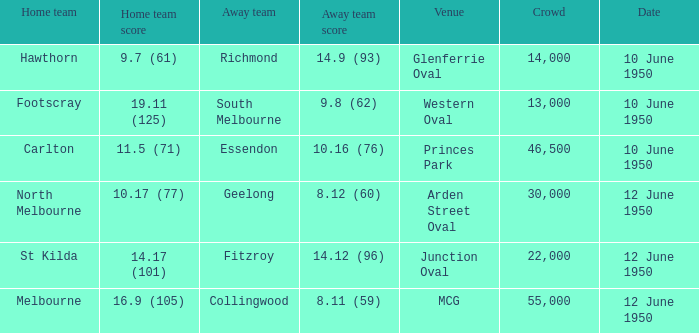What was the gathering when melbourne was the home team? 55000.0. 